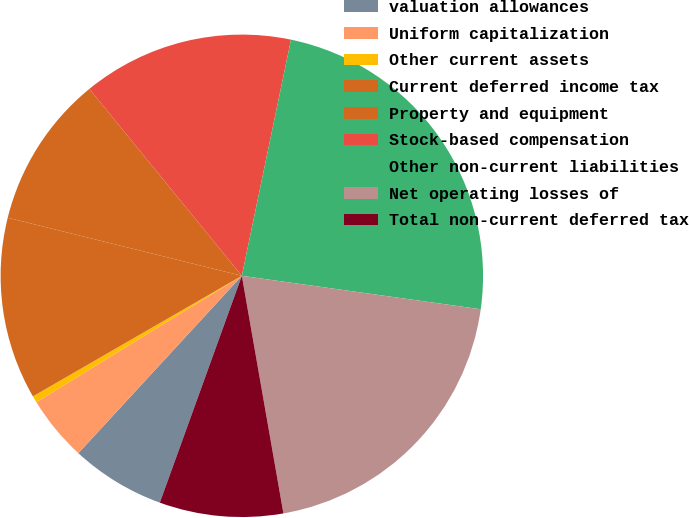Convert chart. <chart><loc_0><loc_0><loc_500><loc_500><pie_chart><fcel>valuation allowances<fcel>Uniform capitalization<fcel>Other current assets<fcel>Current deferred income tax<fcel>Property and equipment<fcel>Stock-based compensation<fcel>Other non-current liabilities<fcel>Net operating losses of<fcel>Total non-current deferred tax<nl><fcel>6.33%<fcel>4.37%<fcel>0.45%<fcel>12.2%<fcel>10.24%<fcel>14.16%<fcel>23.95%<fcel>20.03%<fcel>8.28%<nl></chart> 